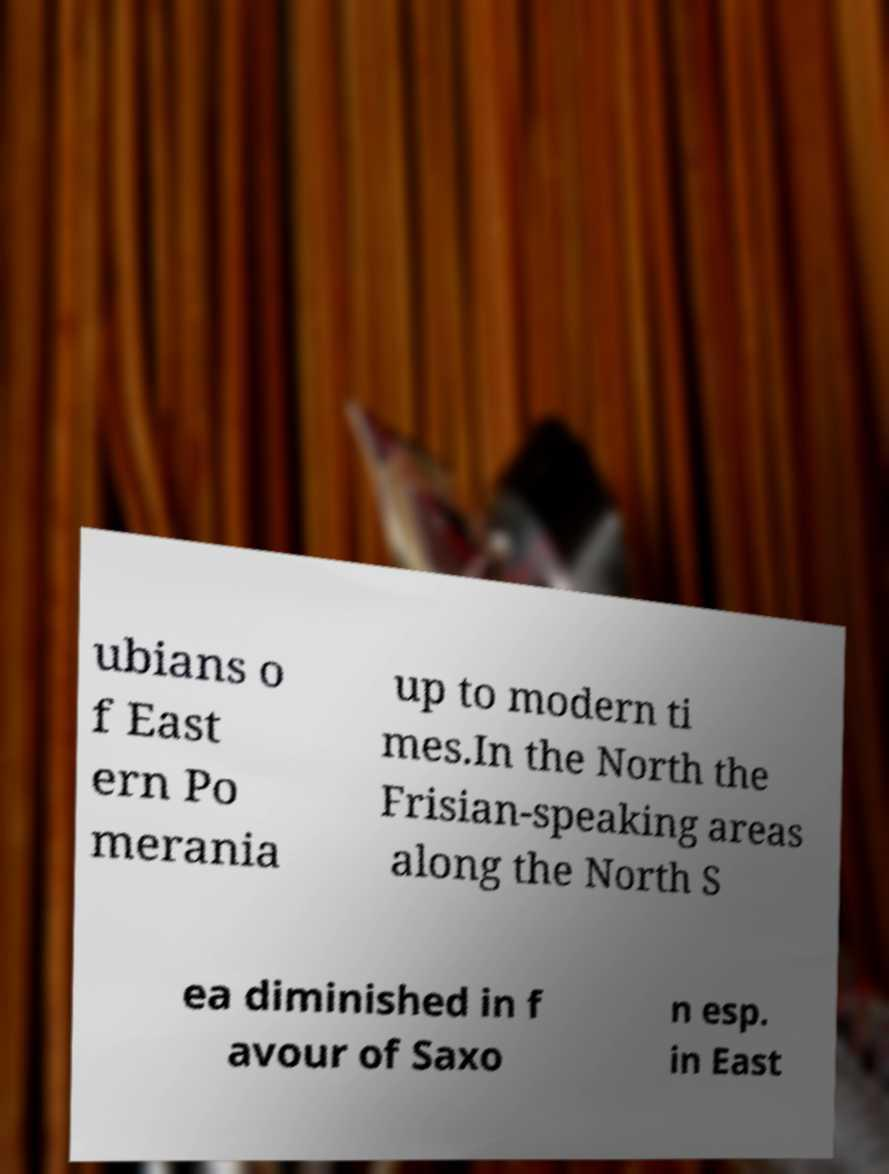Can you read and provide the text displayed in the image?This photo seems to have some interesting text. Can you extract and type it out for me? ubians o f East ern Po merania up to modern ti mes.In the North the Frisian-speaking areas along the North S ea diminished in f avour of Saxo n esp. in East 